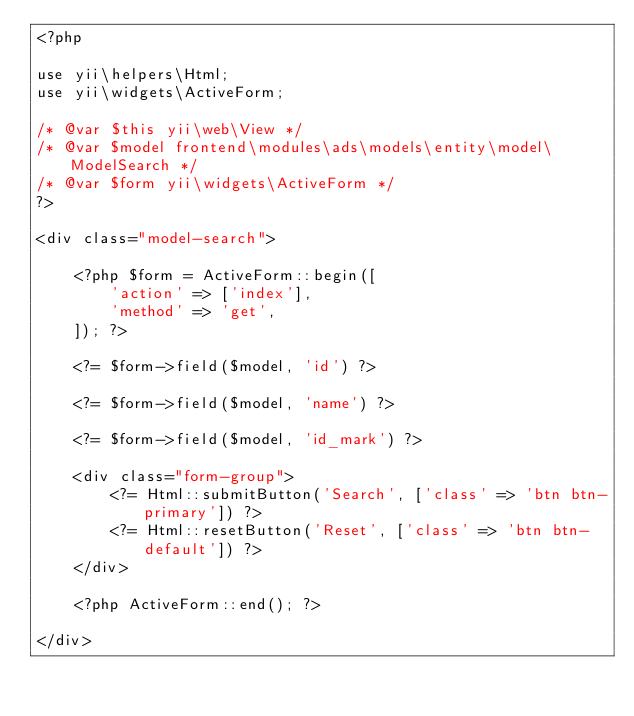<code> <loc_0><loc_0><loc_500><loc_500><_PHP_><?php

use yii\helpers\Html;
use yii\widgets\ActiveForm;

/* @var $this yii\web\View */
/* @var $model frontend\modules\ads\models\entity\model\ModelSearch */
/* @var $form yii\widgets\ActiveForm */
?>

<div class="model-search">

    <?php $form = ActiveForm::begin([
        'action' => ['index'],
        'method' => 'get',
    ]); ?>

    <?= $form->field($model, 'id') ?>

    <?= $form->field($model, 'name') ?>

    <?= $form->field($model, 'id_mark') ?>

    <div class="form-group">
        <?= Html::submitButton('Search', ['class' => 'btn btn-primary']) ?>
        <?= Html::resetButton('Reset', ['class' => 'btn btn-default']) ?>
    </div>

    <?php ActiveForm::end(); ?>

</div>
</code> 